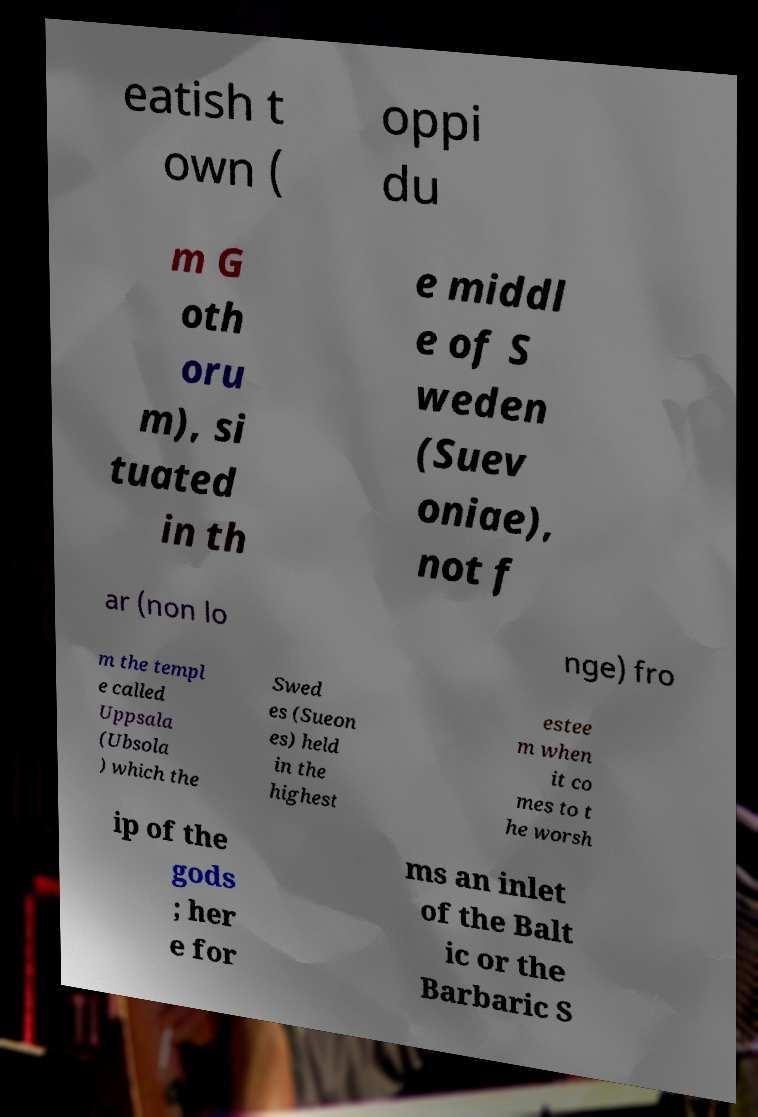There's text embedded in this image that I need extracted. Can you transcribe it verbatim? eatish t own ( oppi du m G oth oru m), si tuated in th e middl e of S weden (Suev oniae), not f ar (non lo nge) fro m the templ e called Uppsala (Ubsola ) which the Swed es (Sueon es) held in the highest estee m when it co mes to t he worsh ip of the gods ; her e for ms an inlet of the Balt ic or the Barbaric S 